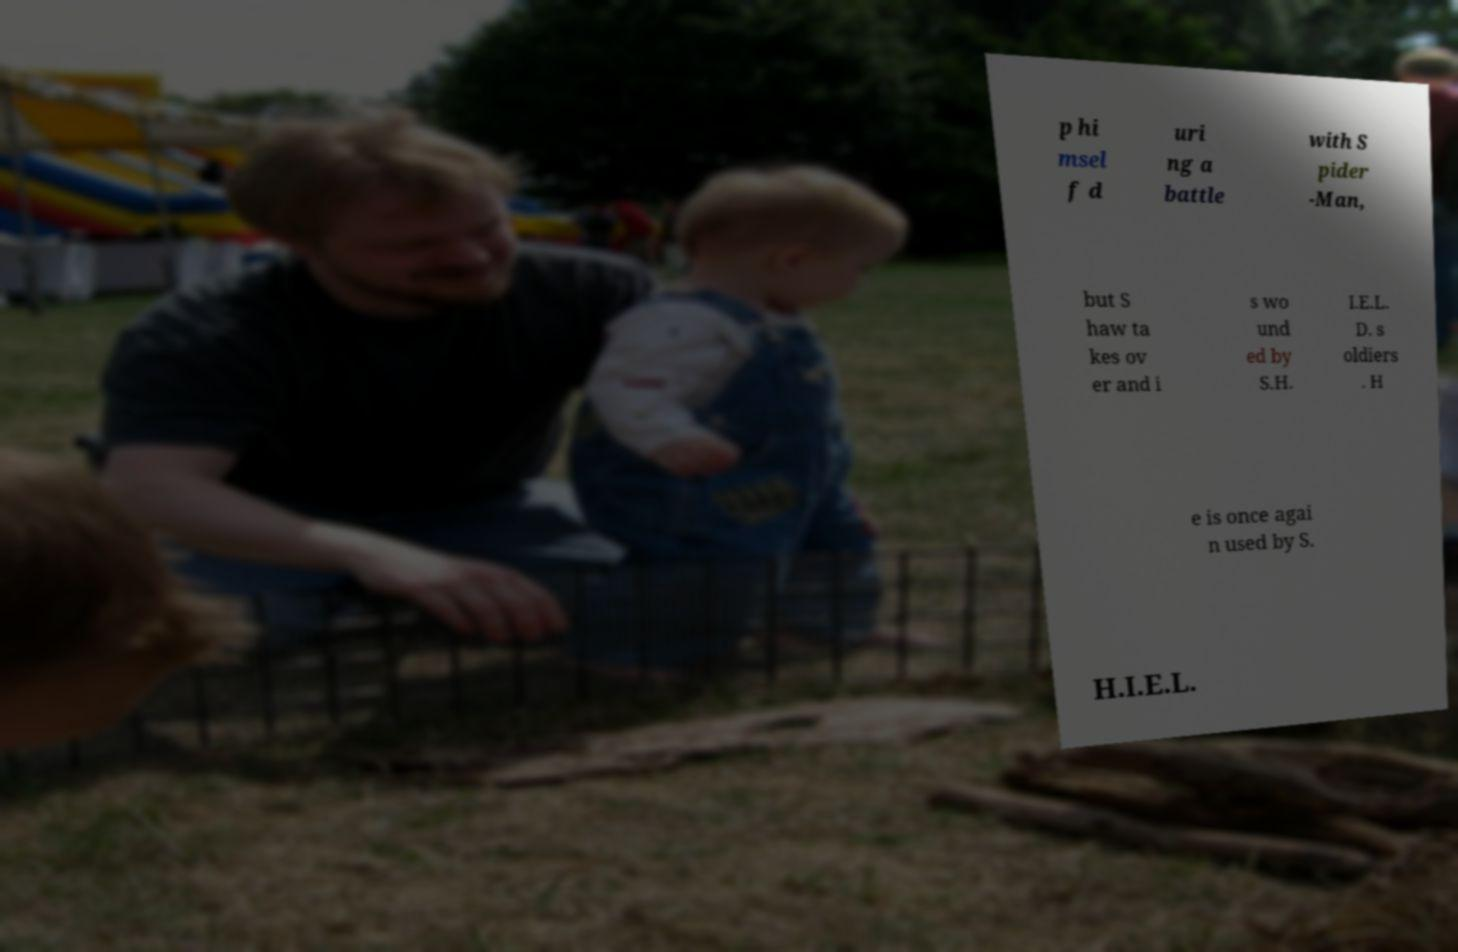Could you extract and type out the text from this image? p hi msel f d uri ng a battle with S pider -Man, but S haw ta kes ov er and i s wo und ed by S.H. I.E.L. D. s oldiers . H e is once agai n used by S. H.I.E.L. 